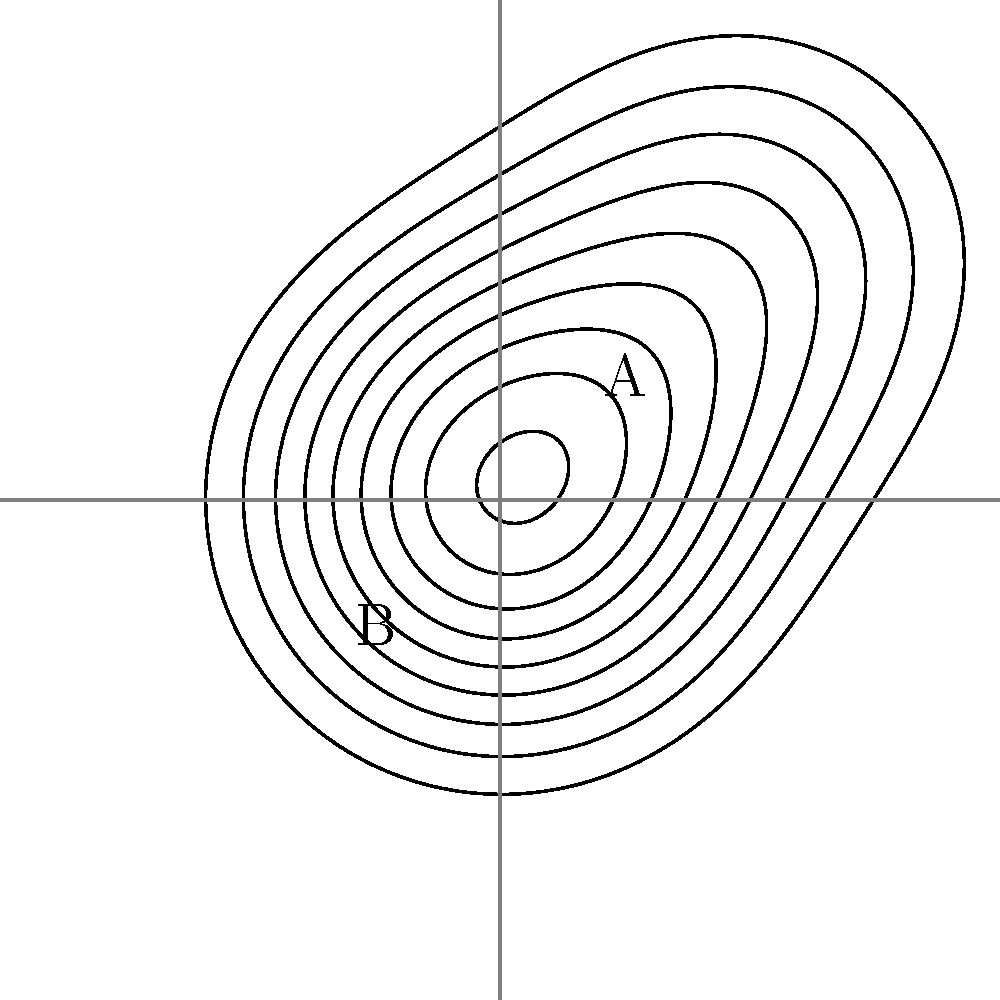In the topographical map above, which point is at a higher elevation: A or B? How can you tell from the contour lines? To interpret topographical contour lines, we need to follow these steps:

1. Understand that contour lines represent points of equal elevation on a map.
2. Recognize that closer contour lines indicate steeper terrain, while wider spacing indicates flatter terrain.
3. Note that elevation increases as you move from outer contour lines to inner contour lines (assuming the center is a peak, not a depression).

In this map:

1. We see concentric contour lines, suggesting a hill or mountain.
2. Point A is located closer to the center of the concentric circles than point B.
3. Since elevation typically increases as you move towards the center of such a formation, we can conclude that point A is at a higher elevation than point B.

Additionally, we can observe that:

4. The contour lines are closer together near point A, indicating steeper terrain and a more rapid change in elevation.
5. The contour lines are farther apart near point B, suggesting gentler slopes and lower elevation.

These observations further support the conclusion that point A is at a higher elevation than point B.
Answer: A is higher; it's closer to the center of concentric contour lines. 